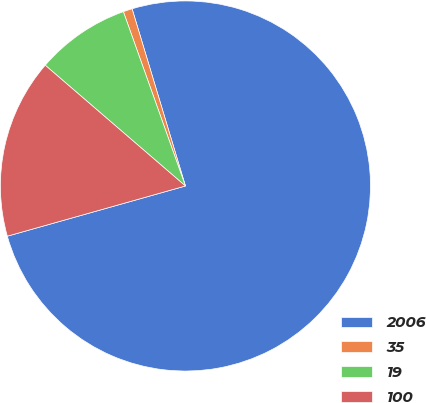Convert chart to OTSL. <chart><loc_0><loc_0><loc_500><loc_500><pie_chart><fcel>2006<fcel>35<fcel>19<fcel>100<nl><fcel>75.29%<fcel>0.79%<fcel>8.24%<fcel>15.69%<nl></chart> 